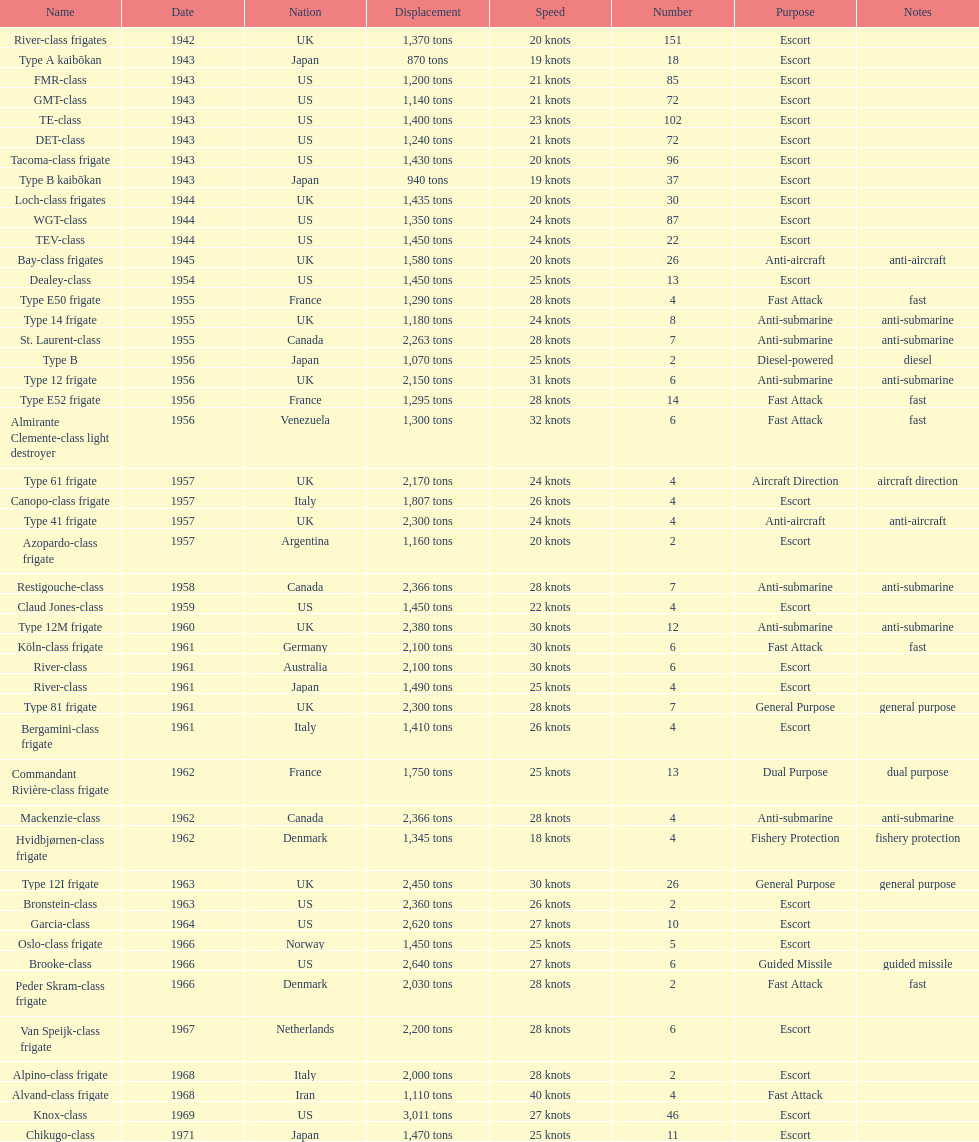What is the difference in speed for the gmt-class and the te-class? 2 knots. 